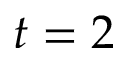Convert formula to latex. <formula><loc_0><loc_0><loc_500><loc_500>t = 2</formula> 